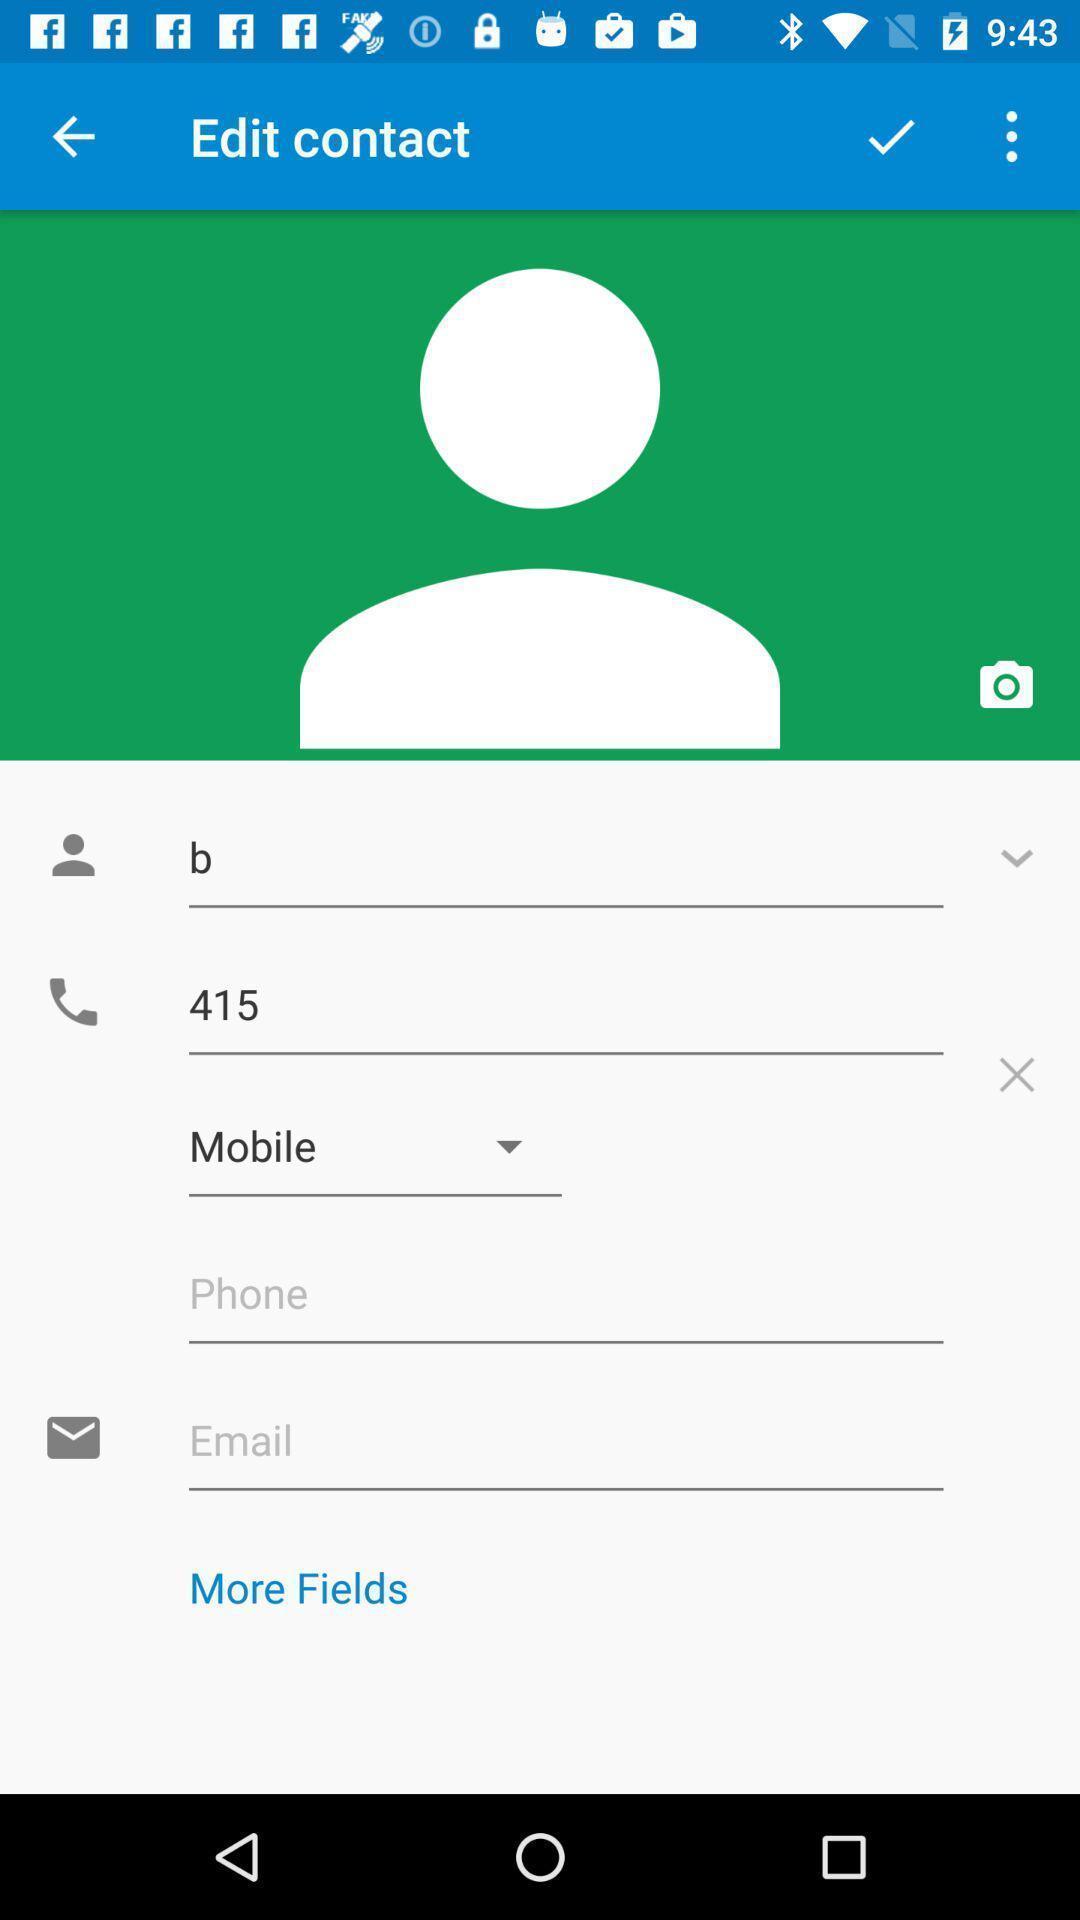What is the overall content of this screenshot? Page shows to edit your contact. 